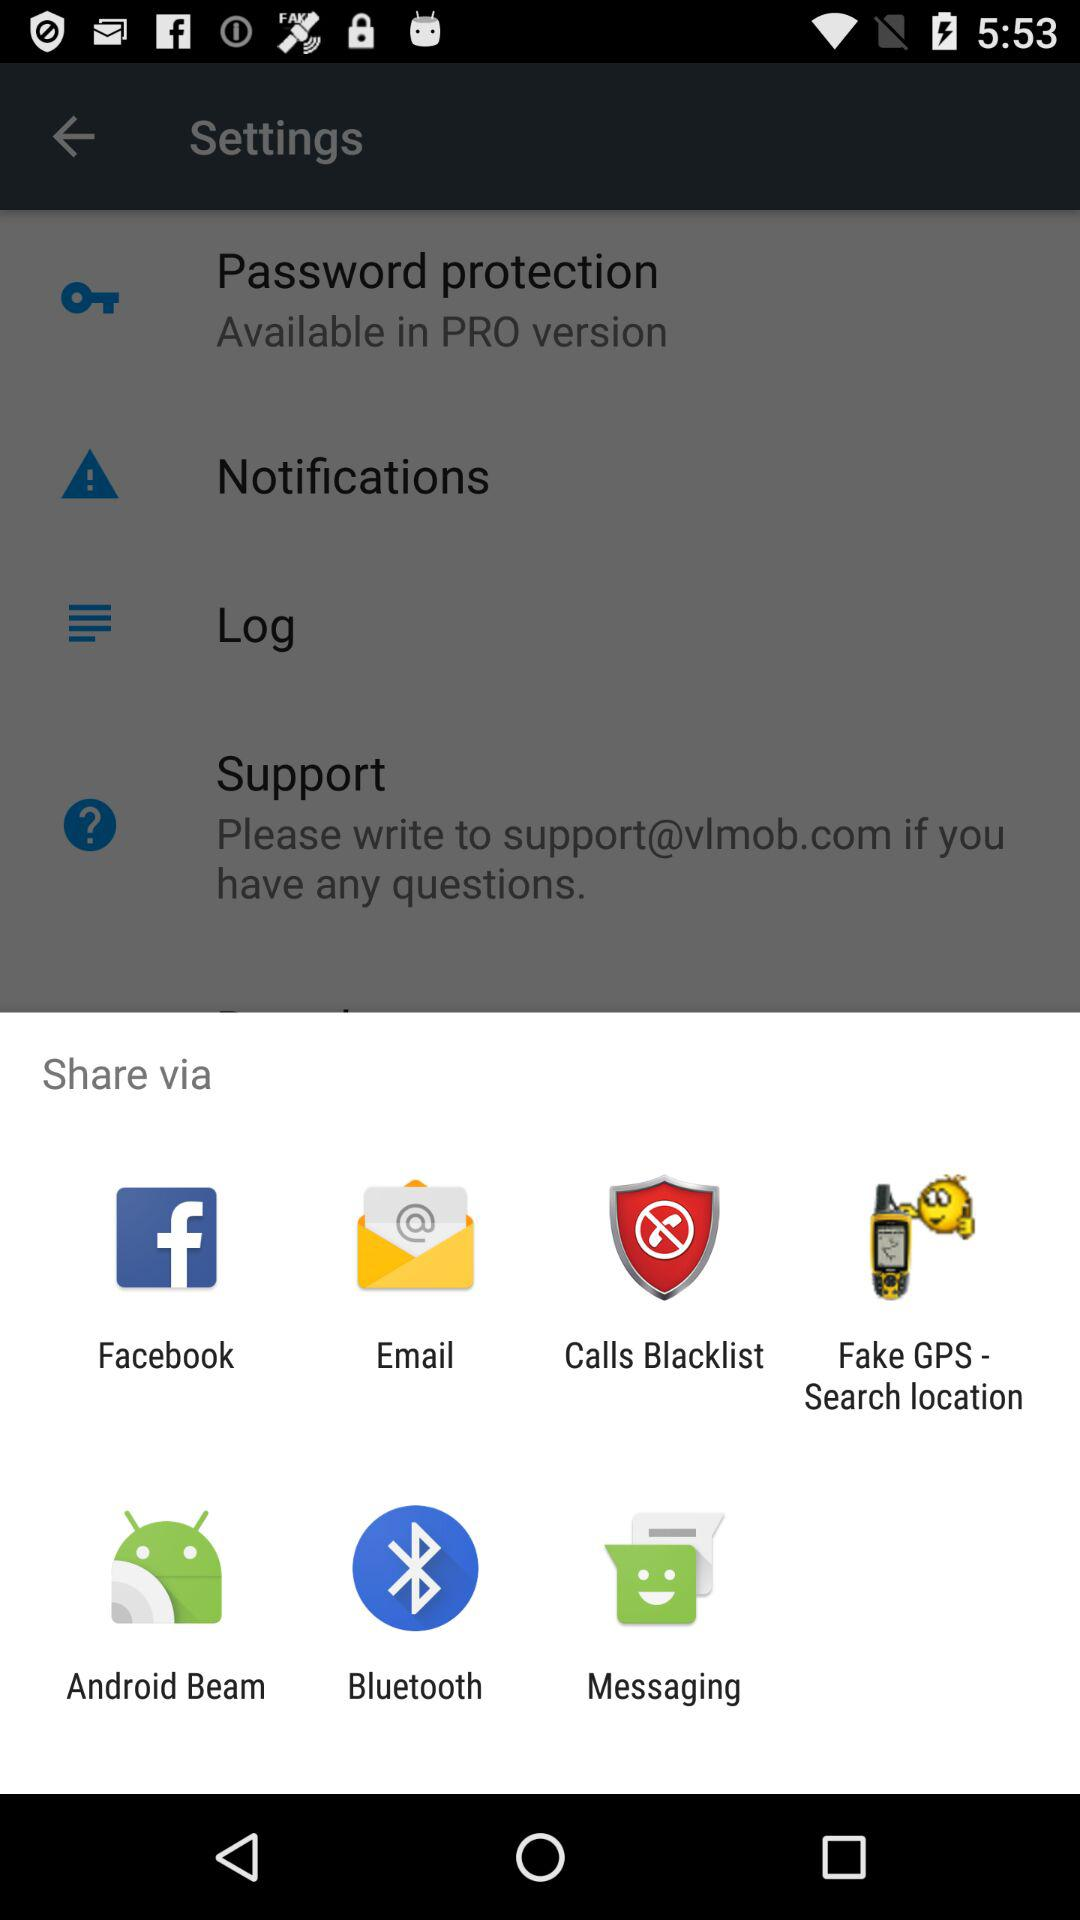Through which applications can we share? You can share through "Facebook", "Email", "Calls Blacklist", "Fake GPS - Search location", "Android Beam", "Bluetooth" and "Messaging". 